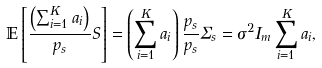Convert formula to latex. <formula><loc_0><loc_0><loc_500><loc_500>\mathbb { E } \left [ \frac { \left ( \sum ^ { K } _ { i = 1 } a _ { i } \right ) } { p _ { s } } S \right ] = \left ( \sum ^ { K } _ { i = 1 } a _ { i } \right ) \frac { p _ { s } } { p _ { s } } \Sigma _ { s } = \sigma ^ { 2 } I _ { m } \sum ^ { K } _ { i = 1 } a _ { i } ,</formula> 